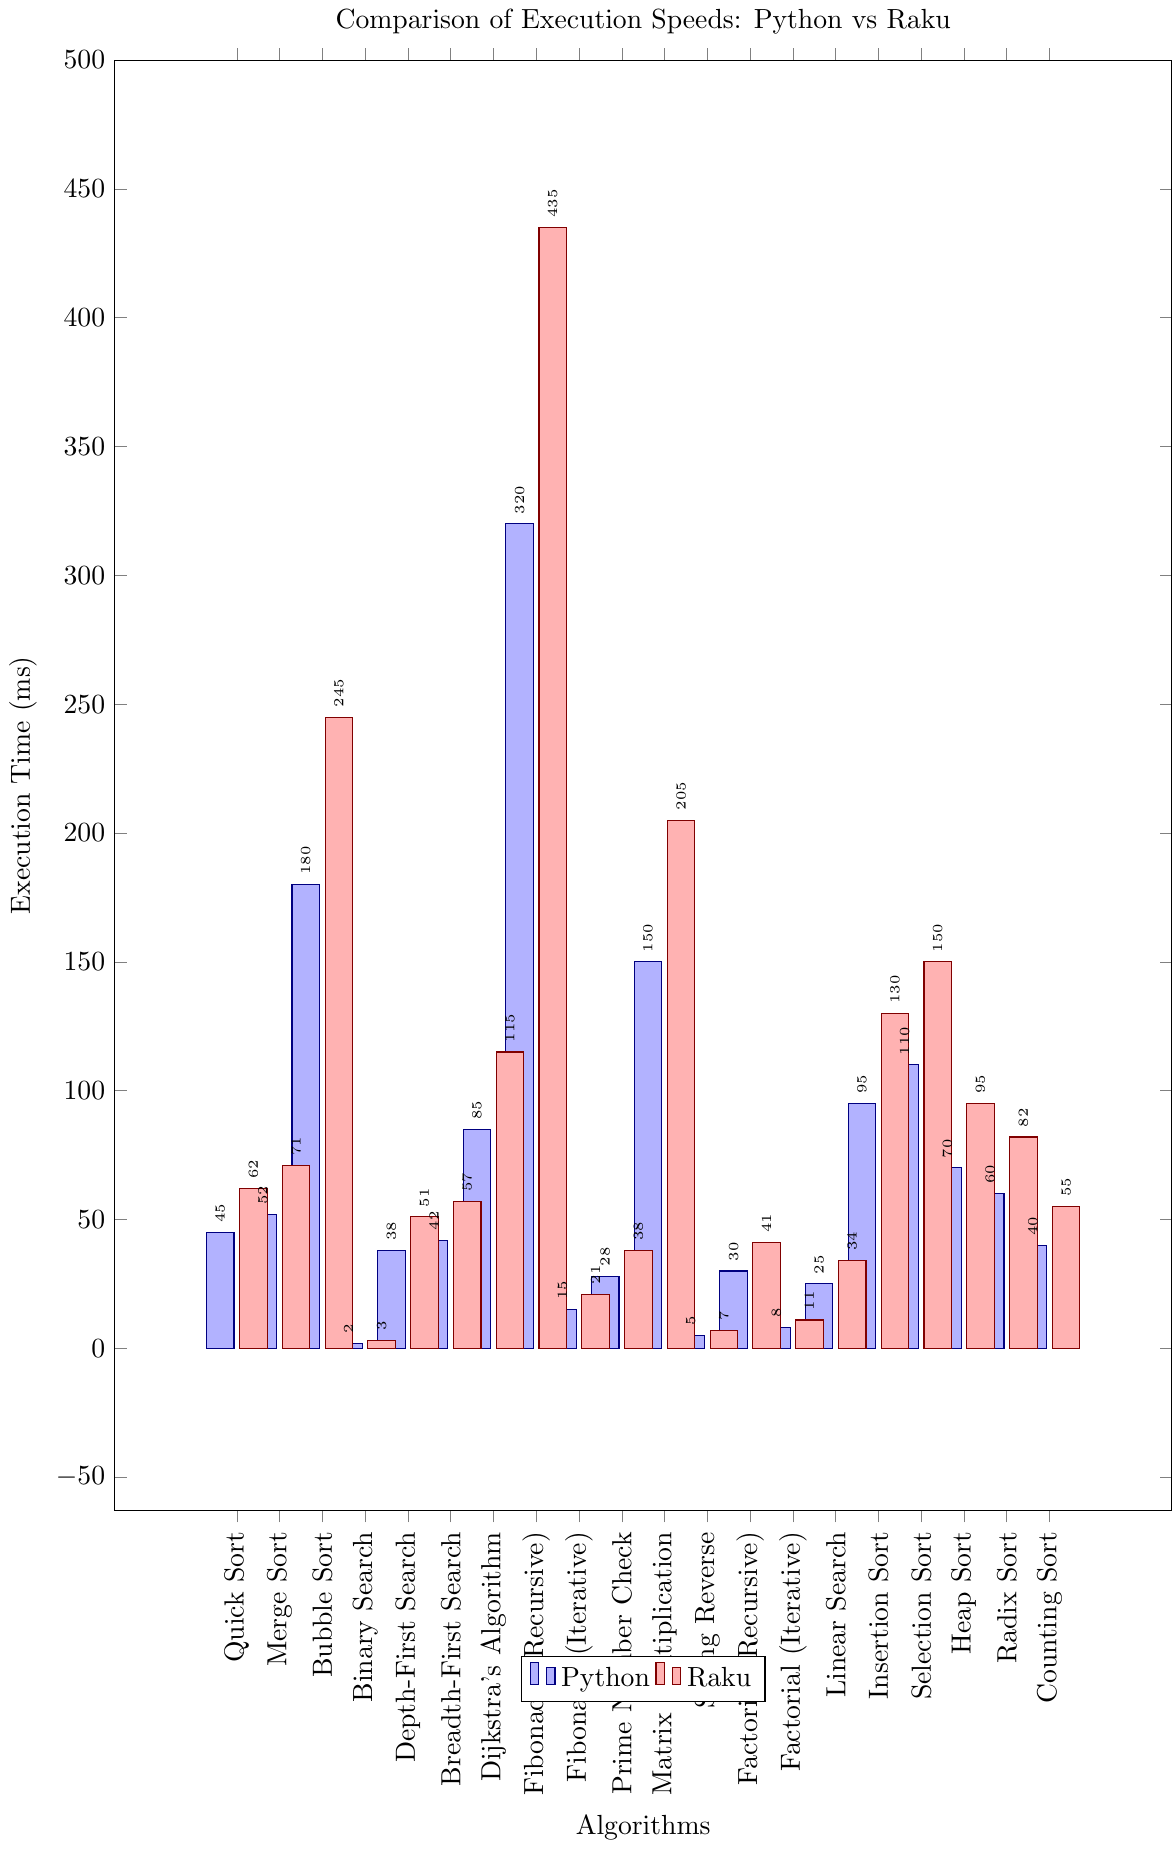Which algorithm has the smallest execution time in Python? By looking for the shortest bar in the Python (blue) category, we can see that the Binary Search algorithm with an execution time of 2 ms is the smallest.
Answer: Binary Search Which algorithm takes longer to execute in Raku than in Python? Comparing the heights of the bars for each algorithm, all algorithms have higher execution times in Raku (red) compared to Python (blue). For example, Quick Sort takes 62 ms in Raku versus 45 ms in Python.
Answer: All algorithms Is the execution time for shortest Binary Search or String Reverse in Raku? Comparing the heights of the bars for Binary Search and String Reverse in Raku (red), Binary Search with 3 ms is shorter than String Reverse with 7 ms.
Answer: Binary Search Which algorithms have execution times less than 50 ms in both Python and Raku? Looking at the bars in both colors that don't exceed the 50 ms mark in both blue and red, the algorithms are Binary Search, String Reverse, and Factorial (Iterative).
Answer: Binary Search, String Reverse, Factorial (Iterative) How much longer does Fibonacci (Recursive) take in Raku compared to Python? Subtract the time taken by Fibonacci (Recursive) in Python from that in Raku: 435 ms (Raku) - 320 ms (Python) = 115 ms.
Answer: 115 ms What is the difference in execution time between the fastest and slowest algorithms in Python? The fastest is Binary Search (2 ms) and the slowest is Fibonacci (Recursive) (320 ms). The difference is 320 ms - 2 ms = 318 ms.
Answer: 318 ms Which algorithm shows the biggest difference in execution time between Python and Raku? By comparing the differences for each algorithm, Fibonacci (Recursive) has the largest difference with 115 ms (435 ms in Raku - 320 ms in Python).
Answer: Fibonacci (Recursive) What is the average execution time of Dijkstra's Algorithm in both Python and Raku? Sum the execution times in both languages and divide by 2: (85 ms for Python + 115 ms for Raku) / 2 = 100 ms.
Answer: 100 ms How many algorithms have an execution time above 200 ms in Raku? Counting the bars in red that exceed the 200 ms mark, we find two algorithms: Bubble Sort (245 ms) and Fibonacci (Recursive) (435 ms).
Answer: 2 Which algorithm has near equal execution times in Python and Raku? By looking for bars that are close in height, Binary Search is the closest with times of 2 ms in Python and 3 ms in Raku.
Answer: Binary Search 